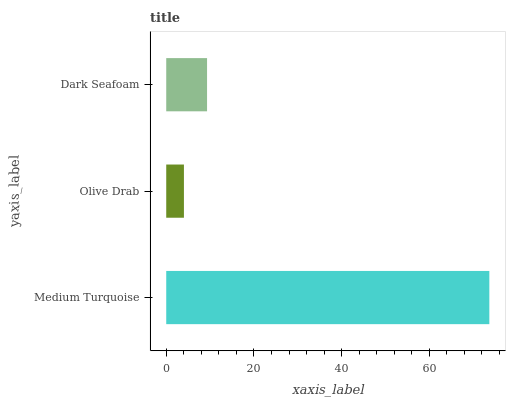Is Olive Drab the minimum?
Answer yes or no. Yes. Is Medium Turquoise the maximum?
Answer yes or no. Yes. Is Dark Seafoam the minimum?
Answer yes or no. No. Is Dark Seafoam the maximum?
Answer yes or no. No. Is Dark Seafoam greater than Olive Drab?
Answer yes or no. Yes. Is Olive Drab less than Dark Seafoam?
Answer yes or no. Yes. Is Olive Drab greater than Dark Seafoam?
Answer yes or no. No. Is Dark Seafoam less than Olive Drab?
Answer yes or no. No. Is Dark Seafoam the high median?
Answer yes or no. Yes. Is Dark Seafoam the low median?
Answer yes or no. Yes. Is Olive Drab the high median?
Answer yes or no. No. Is Olive Drab the low median?
Answer yes or no. No. 